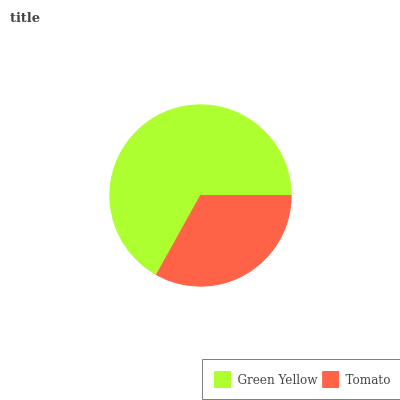Is Tomato the minimum?
Answer yes or no. Yes. Is Green Yellow the maximum?
Answer yes or no. Yes. Is Tomato the maximum?
Answer yes or no. No. Is Green Yellow greater than Tomato?
Answer yes or no. Yes. Is Tomato less than Green Yellow?
Answer yes or no. Yes. Is Tomato greater than Green Yellow?
Answer yes or no. No. Is Green Yellow less than Tomato?
Answer yes or no. No. Is Green Yellow the high median?
Answer yes or no. Yes. Is Tomato the low median?
Answer yes or no. Yes. Is Tomato the high median?
Answer yes or no. No. Is Green Yellow the low median?
Answer yes or no. No. 